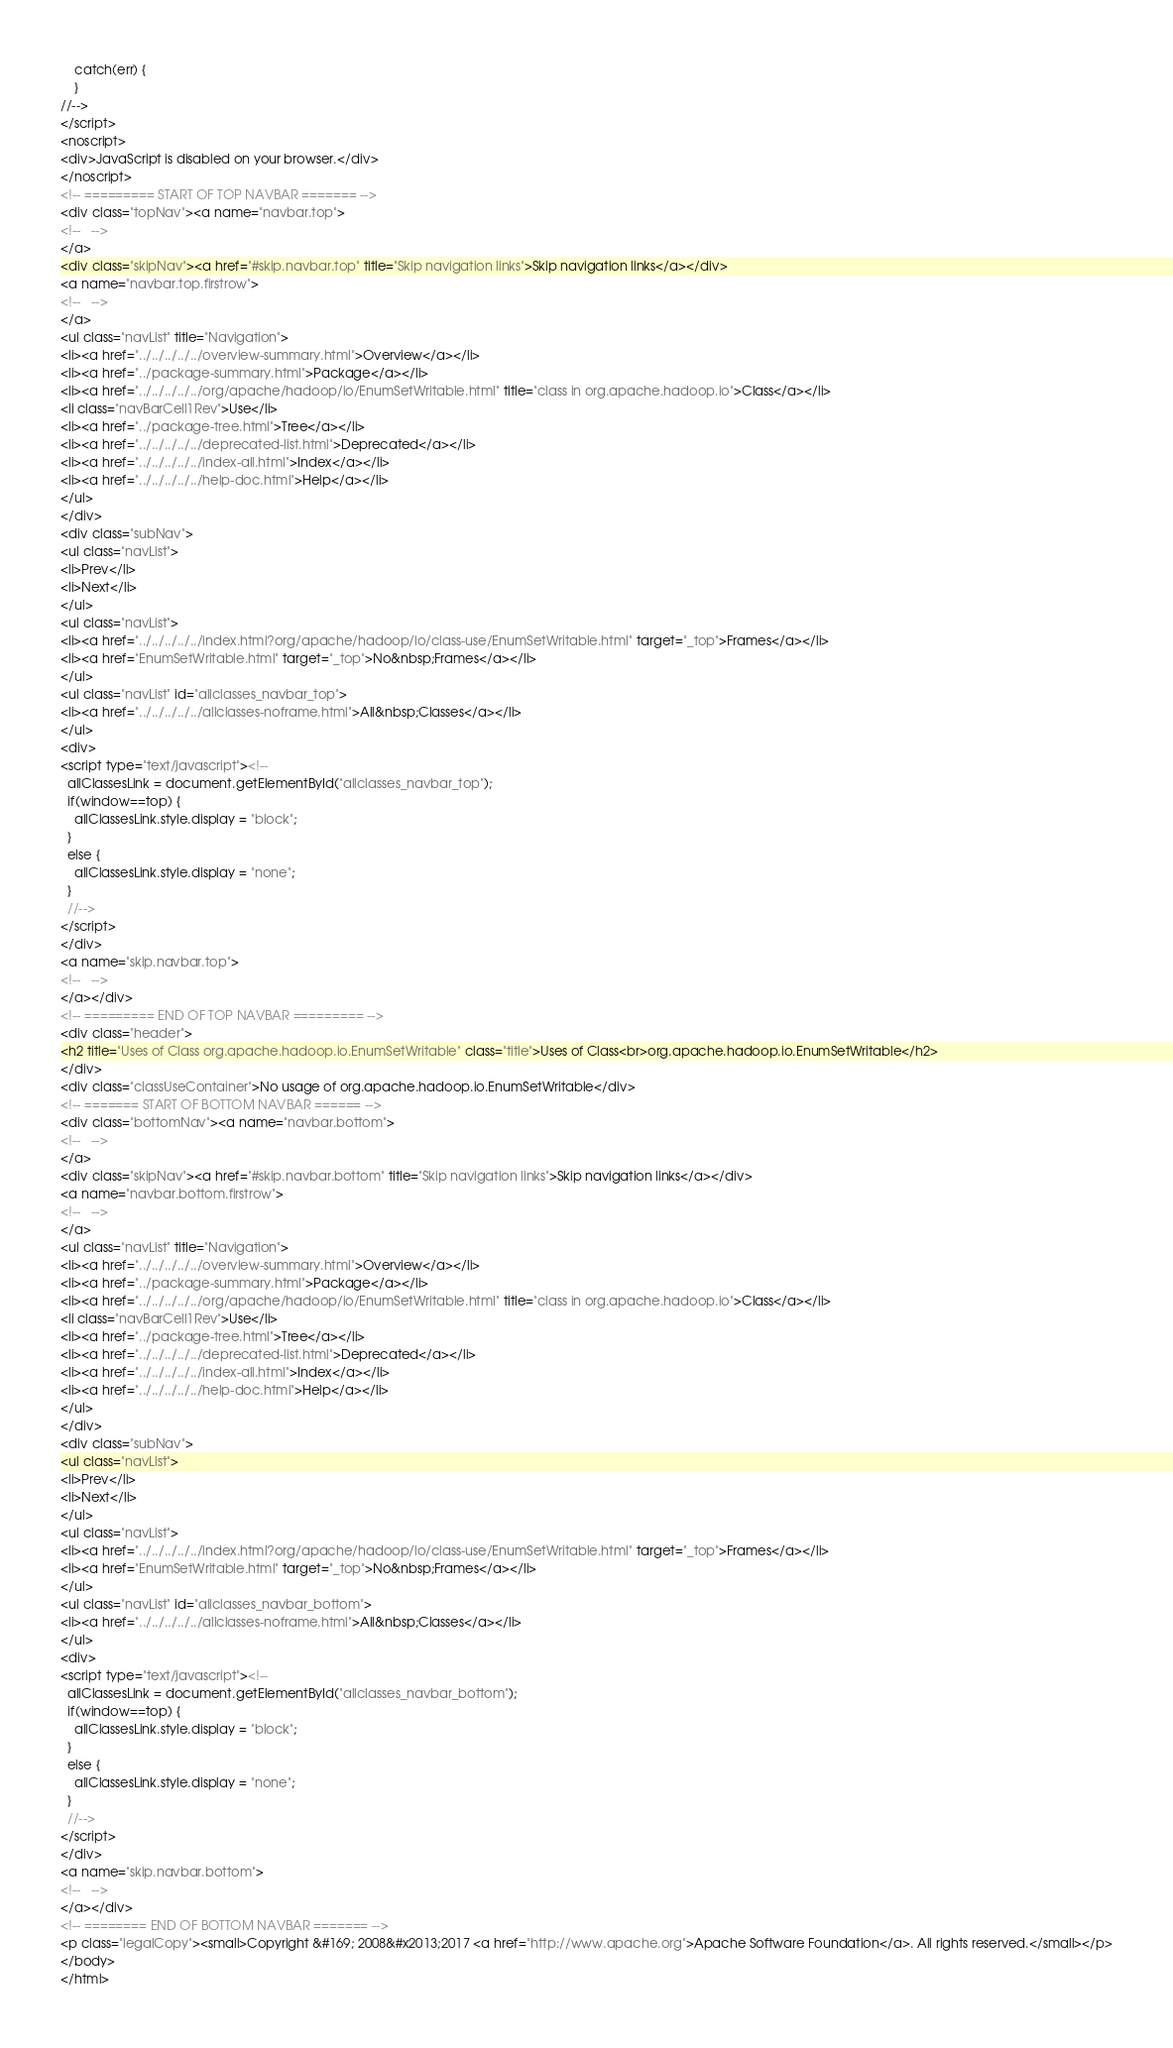<code> <loc_0><loc_0><loc_500><loc_500><_HTML_>    catch(err) {
    }
//-->
</script>
<noscript>
<div>JavaScript is disabled on your browser.</div>
</noscript>
<!-- ========= START OF TOP NAVBAR ======= -->
<div class="topNav"><a name="navbar.top">
<!--   -->
</a>
<div class="skipNav"><a href="#skip.navbar.top" title="Skip navigation links">Skip navigation links</a></div>
<a name="navbar.top.firstrow">
<!--   -->
</a>
<ul class="navList" title="Navigation">
<li><a href="../../../../../overview-summary.html">Overview</a></li>
<li><a href="../package-summary.html">Package</a></li>
<li><a href="../../../../../org/apache/hadoop/io/EnumSetWritable.html" title="class in org.apache.hadoop.io">Class</a></li>
<li class="navBarCell1Rev">Use</li>
<li><a href="../package-tree.html">Tree</a></li>
<li><a href="../../../../../deprecated-list.html">Deprecated</a></li>
<li><a href="../../../../../index-all.html">Index</a></li>
<li><a href="../../../../../help-doc.html">Help</a></li>
</ul>
</div>
<div class="subNav">
<ul class="navList">
<li>Prev</li>
<li>Next</li>
</ul>
<ul class="navList">
<li><a href="../../../../../index.html?org/apache/hadoop/io/class-use/EnumSetWritable.html" target="_top">Frames</a></li>
<li><a href="EnumSetWritable.html" target="_top">No&nbsp;Frames</a></li>
</ul>
<ul class="navList" id="allclasses_navbar_top">
<li><a href="../../../../../allclasses-noframe.html">All&nbsp;Classes</a></li>
</ul>
<div>
<script type="text/javascript"><!--
  allClassesLink = document.getElementById("allclasses_navbar_top");
  if(window==top) {
    allClassesLink.style.display = "block";
  }
  else {
    allClassesLink.style.display = "none";
  }
  //-->
</script>
</div>
<a name="skip.navbar.top">
<!--   -->
</a></div>
<!-- ========= END OF TOP NAVBAR ========= -->
<div class="header">
<h2 title="Uses of Class org.apache.hadoop.io.EnumSetWritable" class="title">Uses of Class<br>org.apache.hadoop.io.EnumSetWritable</h2>
</div>
<div class="classUseContainer">No usage of org.apache.hadoop.io.EnumSetWritable</div>
<!-- ======= START OF BOTTOM NAVBAR ====== -->
<div class="bottomNav"><a name="navbar.bottom">
<!--   -->
</a>
<div class="skipNav"><a href="#skip.navbar.bottom" title="Skip navigation links">Skip navigation links</a></div>
<a name="navbar.bottom.firstrow">
<!--   -->
</a>
<ul class="navList" title="Navigation">
<li><a href="../../../../../overview-summary.html">Overview</a></li>
<li><a href="../package-summary.html">Package</a></li>
<li><a href="../../../../../org/apache/hadoop/io/EnumSetWritable.html" title="class in org.apache.hadoop.io">Class</a></li>
<li class="navBarCell1Rev">Use</li>
<li><a href="../package-tree.html">Tree</a></li>
<li><a href="../../../../../deprecated-list.html">Deprecated</a></li>
<li><a href="../../../../../index-all.html">Index</a></li>
<li><a href="../../../../../help-doc.html">Help</a></li>
</ul>
</div>
<div class="subNav">
<ul class="navList">
<li>Prev</li>
<li>Next</li>
</ul>
<ul class="navList">
<li><a href="../../../../../index.html?org/apache/hadoop/io/class-use/EnumSetWritable.html" target="_top">Frames</a></li>
<li><a href="EnumSetWritable.html" target="_top">No&nbsp;Frames</a></li>
</ul>
<ul class="navList" id="allclasses_navbar_bottom">
<li><a href="../../../../../allclasses-noframe.html">All&nbsp;Classes</a></li>
</ul>
<div>
<script type="text/javascript"><!--
  allClassesLink = document.getElementById("allclasses_navbar_bottom");
  if(window==top) {
    allClassesLink.style.display = "block";
  }
  else {
    allClassesLink.style.display = "none";
  }
  //-->
</script>
</div>
<a name="skip.navbar.bottom">
<!--   -->
</a></div>
<!-- ======== END OF BOTTOM NAVBAR ======= -->
<p class="legalCopy"><small>Copyright &#169; 2008&#x2013;2017 <a href="http://www.apache.org">Apache Software Foundation</a>. All rights reserved.</small></p>
</body>
</html>
</code> 